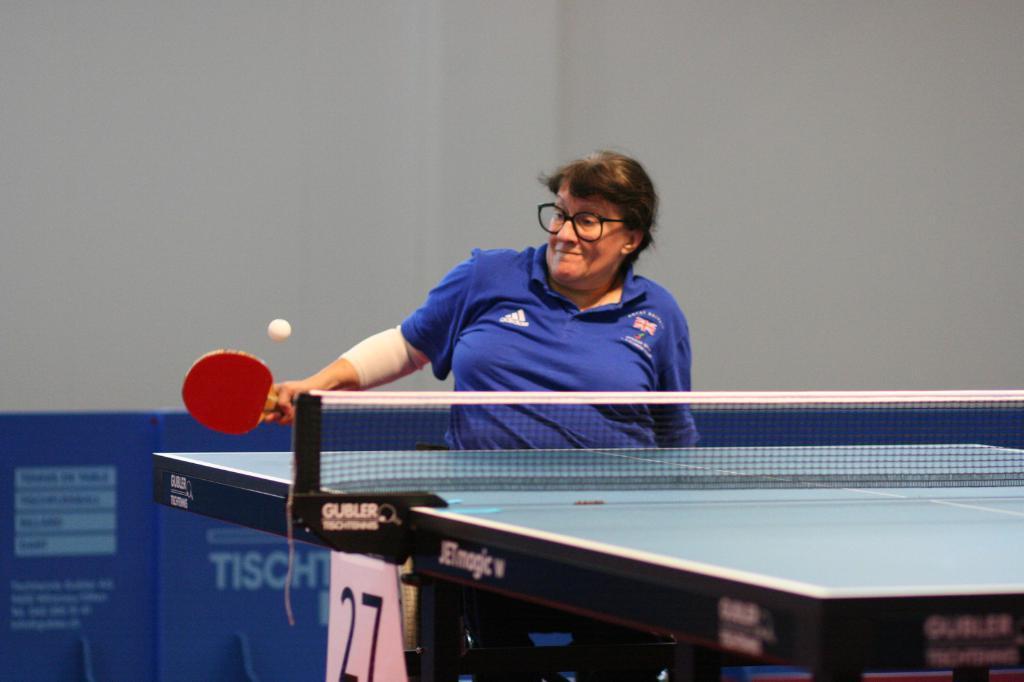Can you describe this image briefly? In this image we can see a person holding a racket and in a position to hit a ball. Here we can see table tennis, mesh, and a board. In the background we can see a wall and hoarding. 